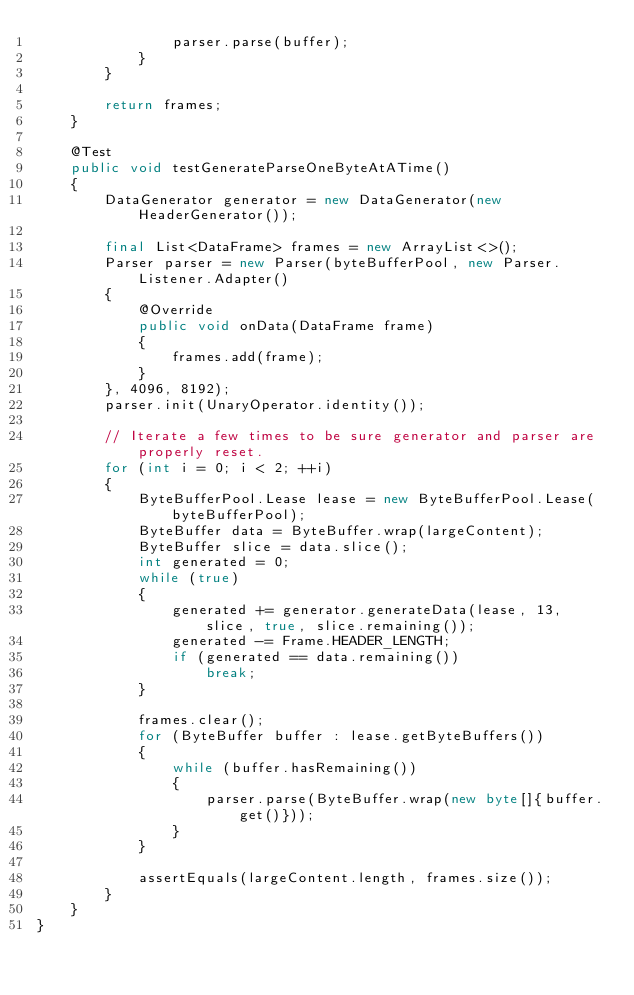<code> <loc_0><loc_0><loc_500><loc_500><_Java_>                parser.parse(buffer);
            }
        }

        return frames;
    }

    @Test
    public void testGenerateParseOneByteAtATime()
    {
        DataGenerator generator = new DataGenerator(new HeaderGenerator());

        final List<DataFrame> frames = new ArrayList<>();
        Parser parser = new Parser(byteBufferPool, new Parser.Listener.Adapter()
        {
            @Override
            public void onData(DataFrame frame)
            {
                frames.add(frame);
            }
        }, 4096, 8192);
        parser.init(UnaryOperator.identity());

        // Iterate a few times to be sure generator and parser are properly reset.
        for (int i = 0; i < 2; ++i)
        {
            ByteBufferPool.Lease lease = new ByteBufferPool.Lease(byteBufferPool);
            ByteBuffer data = ByteBuffer.wrap(largeContent);
            ByteBuffer slice = data.slice();
            int generated = 0;
            while (true)
            {
                generated += generator.generateData(lease, 13, slice, true, slice.remaining());
                generated -= Frame.HEADER_LENGTH;
                if (generated == data.remaining())
                    break;
            }

            frames.clear();
            for (ByteBuffer buffer : lease.getByteBuffers())
            {
                while (buffer.hasRemaining())
                {
                    parser.parse(ByteBuffer.wrap(new byte[]{buffer.get()}));
                }
            }

            assertEquals(largeContent.length, frames.size());
        }
    }
}
</code> 